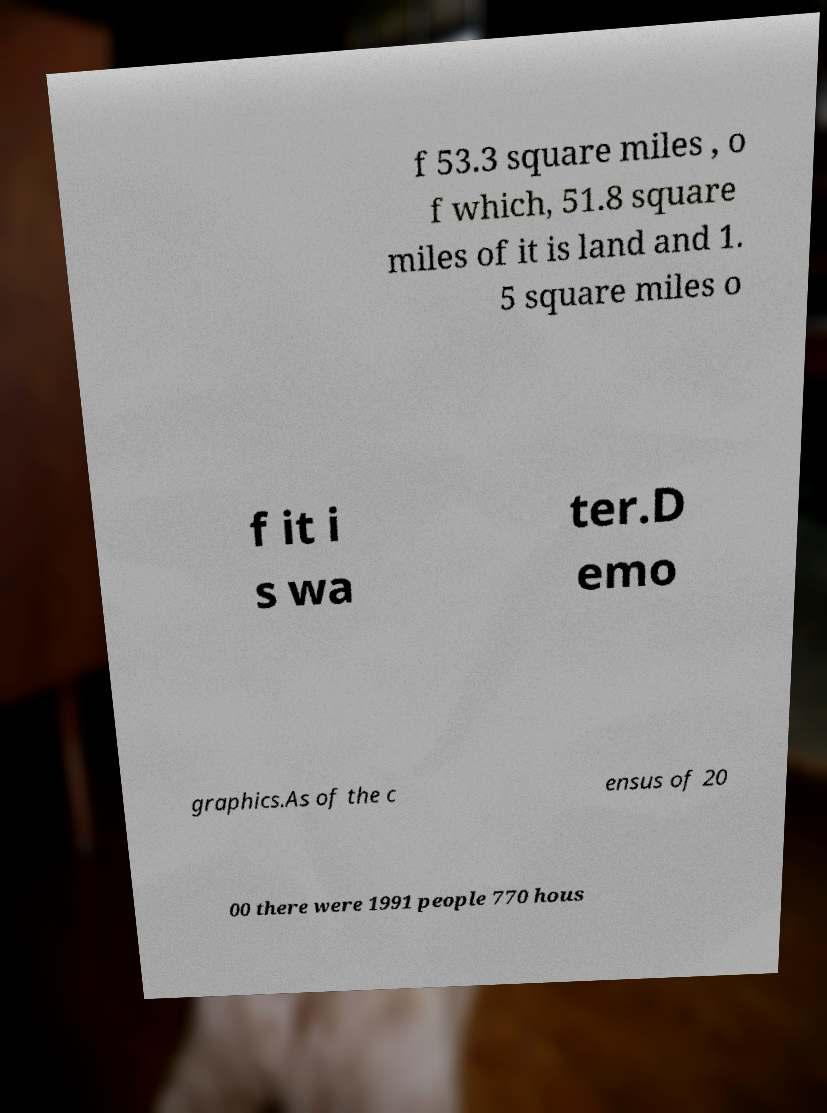I need the written content from this picture converted into text. Can you do that? f 53.3 square miles , o f which, 51.8 square miles of it is land and 1. 5 square miles o f it i s wa ter.D emo graphics.As of the c ensus of 20 00 there were 1991 people 770 hous 